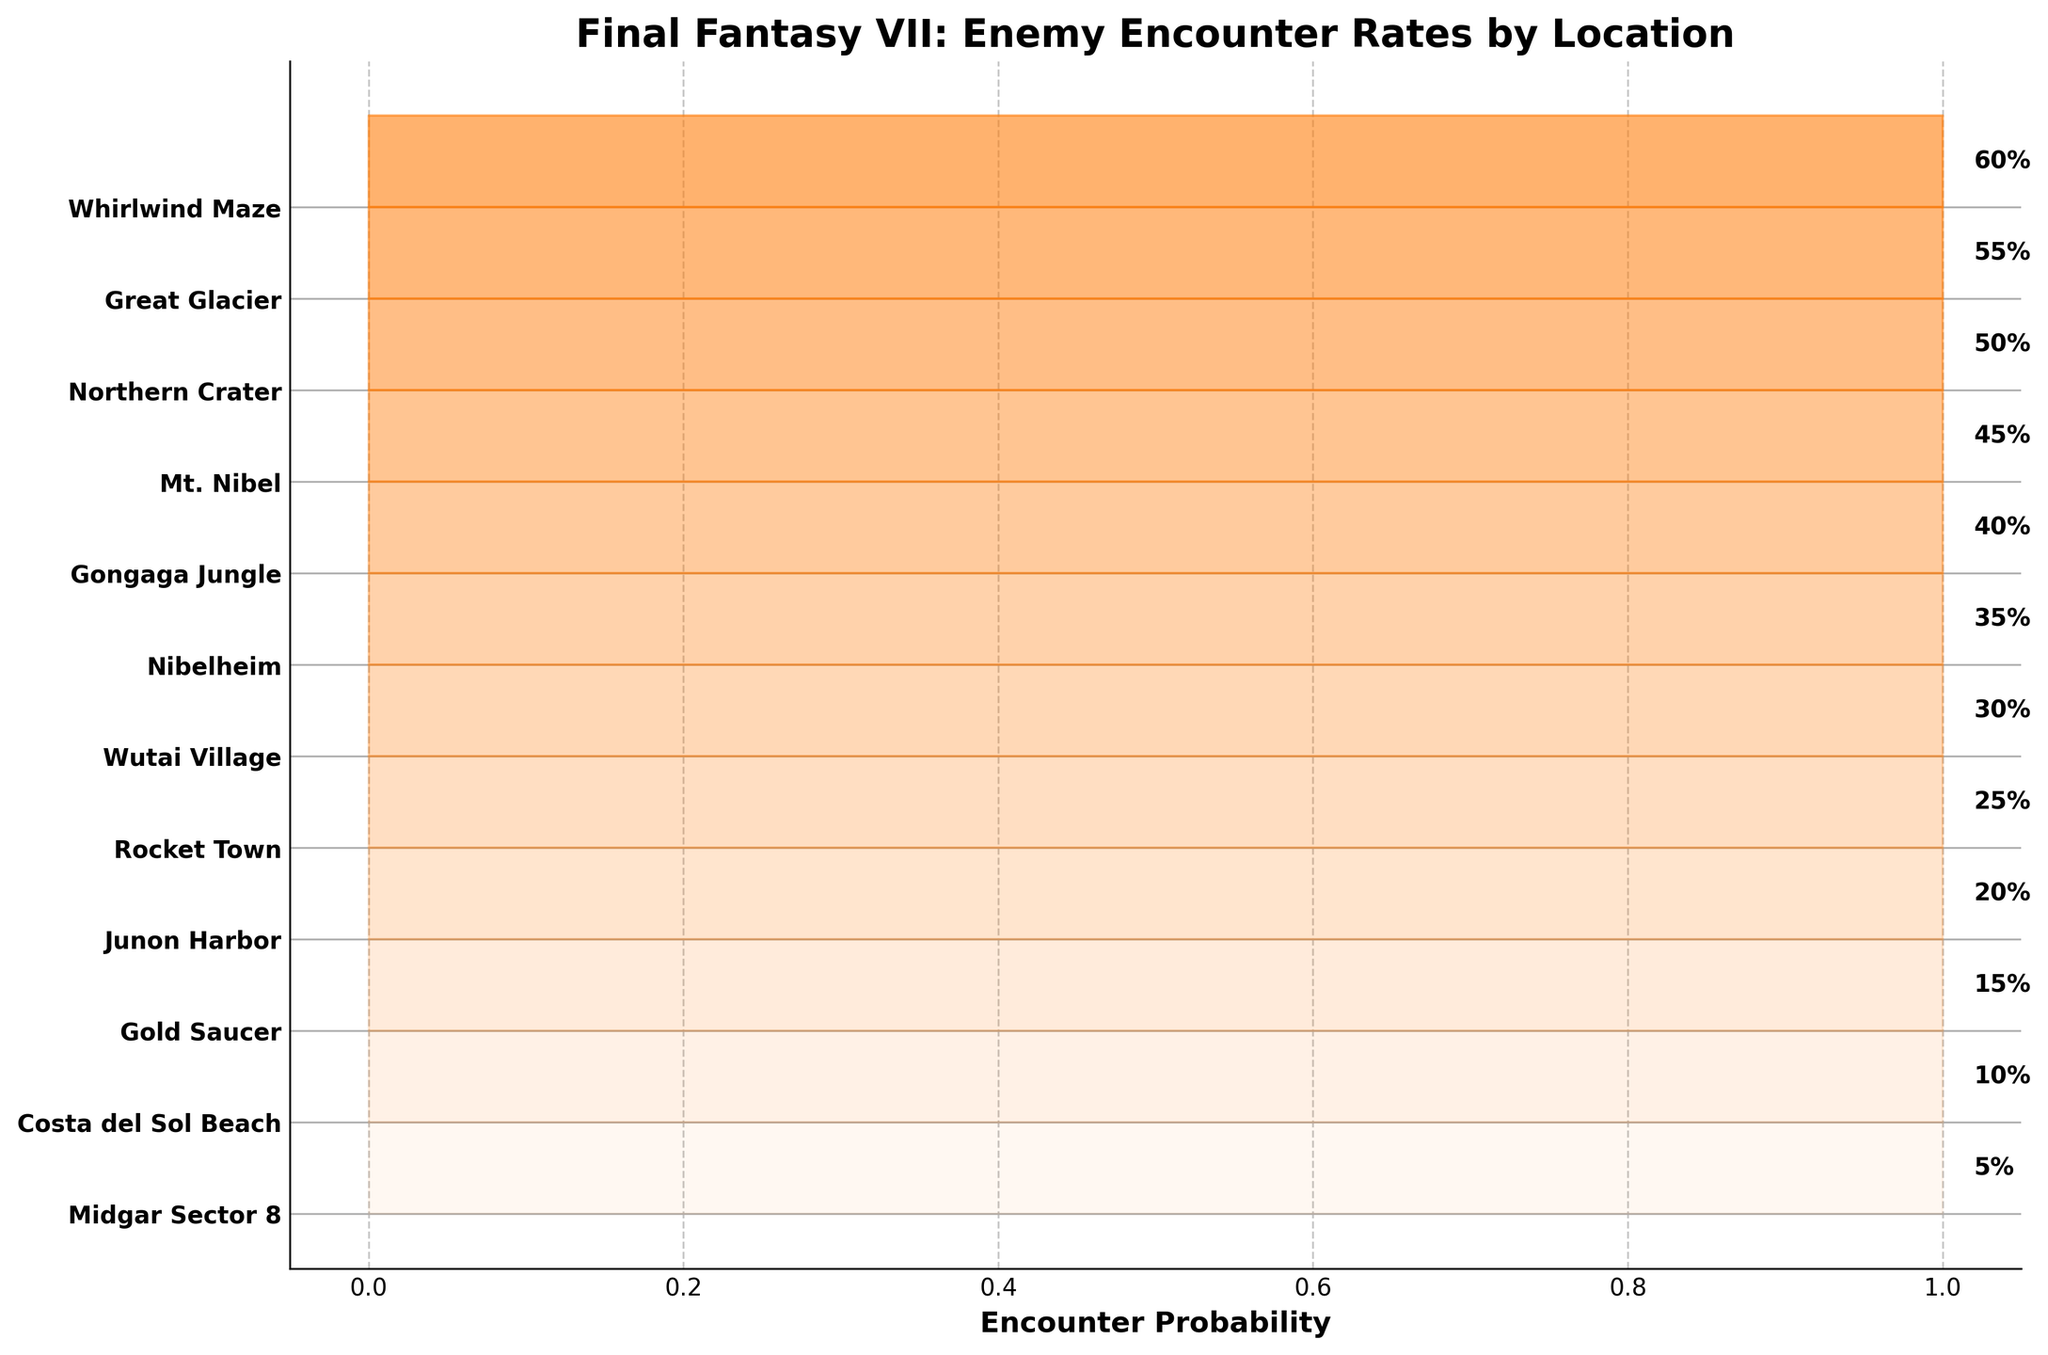What is the title of the chart? The title is typically located at the top of the chart and describes what the chart represents.
Answer: Final Fantasy VII: Enemy Encounter Rates by Location Which location has the highest enemy encounter rate? The highest encounter rate is the location with the greatest filling within the fan chart bands and the biggest numerical rate on the right side.
Answer: Whirlwind Maze What is the encounter rate for Midgar Sector 8? Find the rate next to "Midgar Sector 8" on the right side of the chart.
Answer: 5% Which locations have an encounter rate less than 20%? Identify the locations corresponding to encounter rates less than 20% on the right side of the chart.
Answer: Midgar Sector 8, Costa del Sol Beach, Gold Saucer What is the difference in encounter rate between Northern Crater and Junon Harbor? Locate the Northern Crater and Junon Harbor rates on the chart, then calculate their difference.
Answer: 30% What is the average encounter rate across all locations? Sum all encounter rates and divide by the number of locations (12).
Answer: 32.5% How many locations have an encounter rate of 40% or higher? Identify and count the locations with encounter rates equal to or greater than 40% on the right side of the chart.
Answer: 5 How does the encounter rate in Gold Saucer compare to that of Rocket Town? Compare the encounter rates next to these two locations.
Answer: Gold Saucer's rate is lower than Rocket Town's What pattern can you observe in the encounter rates across locations? Examine and interpret the progression of the encounter rates visually represented in the fan chart.
Answer: Encounter rates generally increase as you move down the list of locations Which location sees a notable increase in encounter rate when compared to the previous location? Find a location where the encounter rate difference from the previous one is significantly large.
Answer: Mt. Nibel (compared to Gongaga Jungle) 